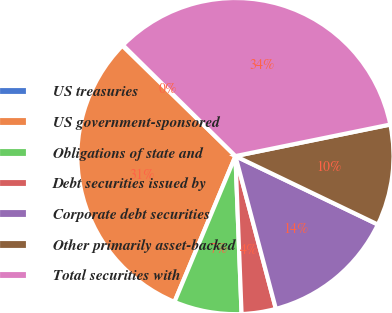Convert chart. <chart><loc_0><loc_0><loc_500><loc_500><pie_chart><fcel>US treasuries<fcel>US government-sponsored<fcel>Obligations of state and<fcel>Debt securities issued by<fcel>Corporate debt securities<fcel>Other primarily asset-backed<fcel>Total securities with<nl><fcel>0.09%<fcel>31.0%<fcel>6.92%<fcel>3.5%<fcel>13.75%<fcel>10.33%<fcel>34.41%<nl></chart> 